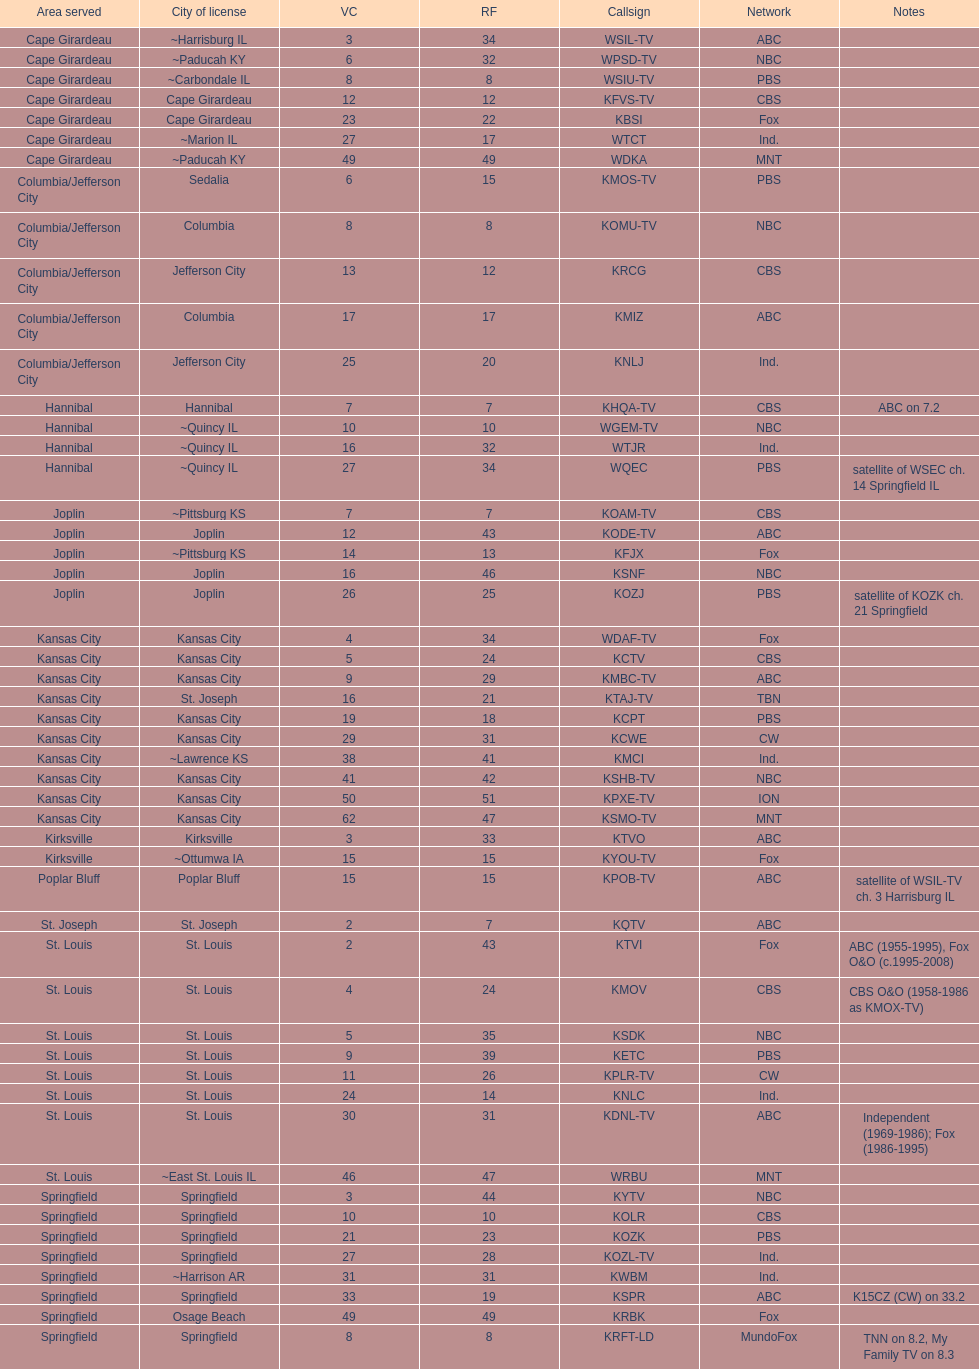What is the total number of cbs stations? 7. 